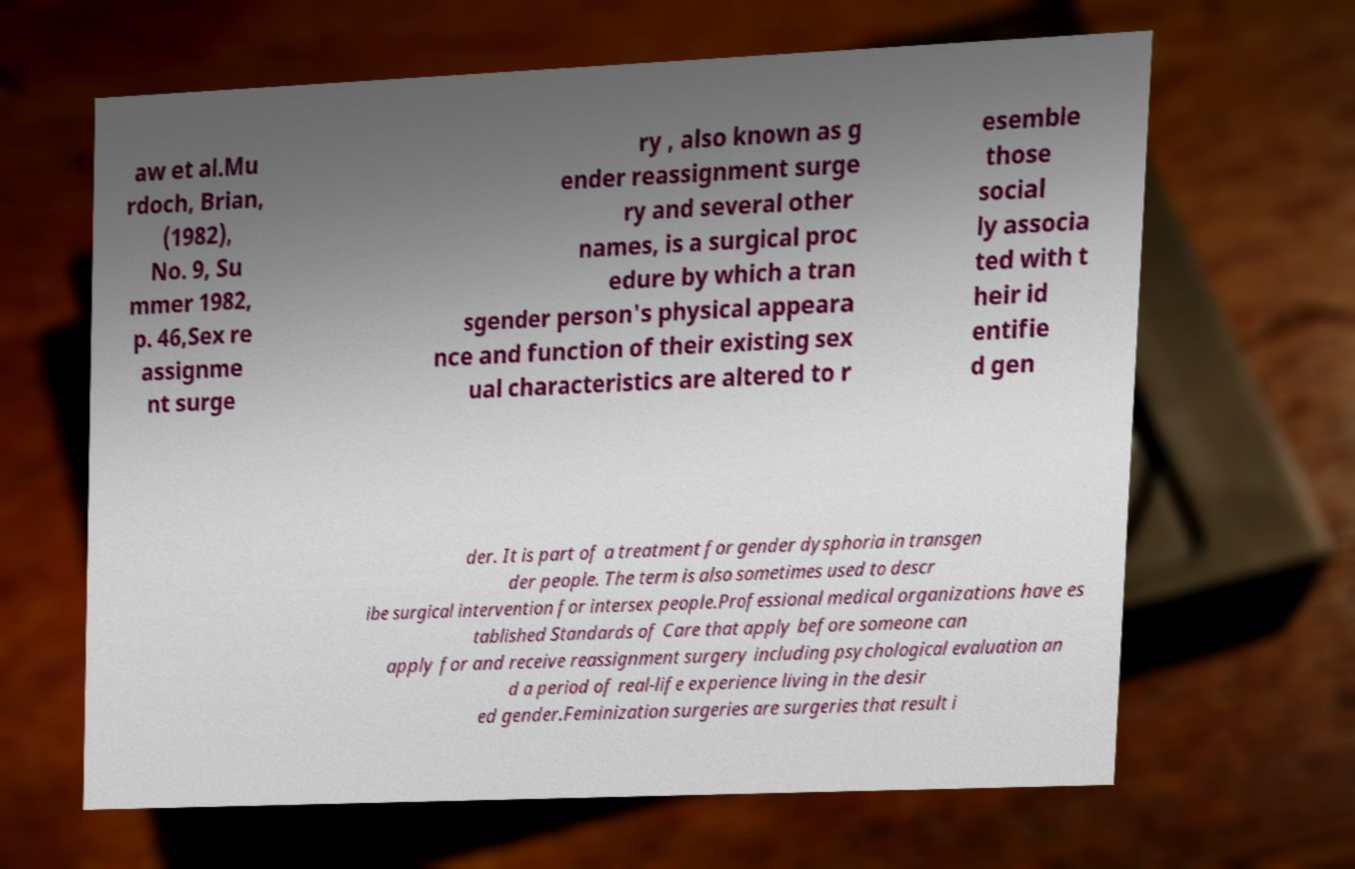There's text embedded in this image that I need extracted. Can you transcribe it verbatim? aw et al.Mu rdoch, Brian, (1982), No. 9, Su mmer 1982, p. 46,Sex re assignme nt surge ry , also known as g ender reassignment surge ry and several other names, is a surgical proc edure by which a tran sgender person's physical appeara nce and function of their existing sex ual characteristics are altered to r esemble those social ly associa ted with t heir id entifie d gen der. It is part of a treatment for gender dysphoria in transgen der people. The term is also sometimes used to descr ibe surgical intervention for intersex people.Professional medical organizations have es tablished Standards of Care that apply before someone can apply for and receive reassignment surgery including psychological evaluation an d a period of real-life experience living in the desir ed gender.Feminization surgeries are surgeries that result i 